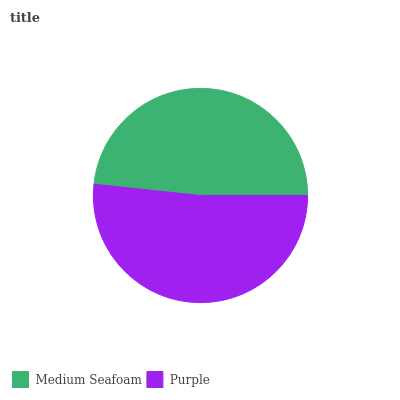Is Medium Seafoam the minimum?
Answer yes or no. Yes. Is Purple the maximum?
Answer yes or no. Yes. Is Purple the minimum?
Answer yes or no. No. Is Purple greater than Medium Seafoam?
Answer yes or no. Yes. Is Medium Seafoam less than Purple?
Answer yes or no. Yes. Is Medium Seafoam greater than Purple?
Answer yes or no. No. Is Purple less than Medium Seafoam?
Answer yes or no. No. Is Purple the high median?
Answer yes or no. Yes. Is Medium Seafoam the low median?
Answer yes or no. Yes. Is Medium Seafoam the high median?
Answer yes or no. No. Is Purple the low median?
Answer yes or no. No. 